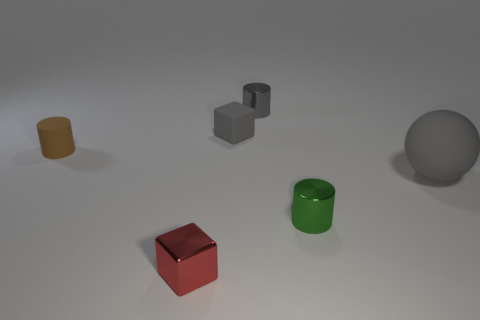What is the material of the big sphere that is to the right of the small gray matte cube? Based on the appearance in the image, the big sphere on the right of the small gray matte cube seems to be made of a smooth, possibly reflective material, which gives it a shiny appearance that could suggest a material like polished metal or plastic. 